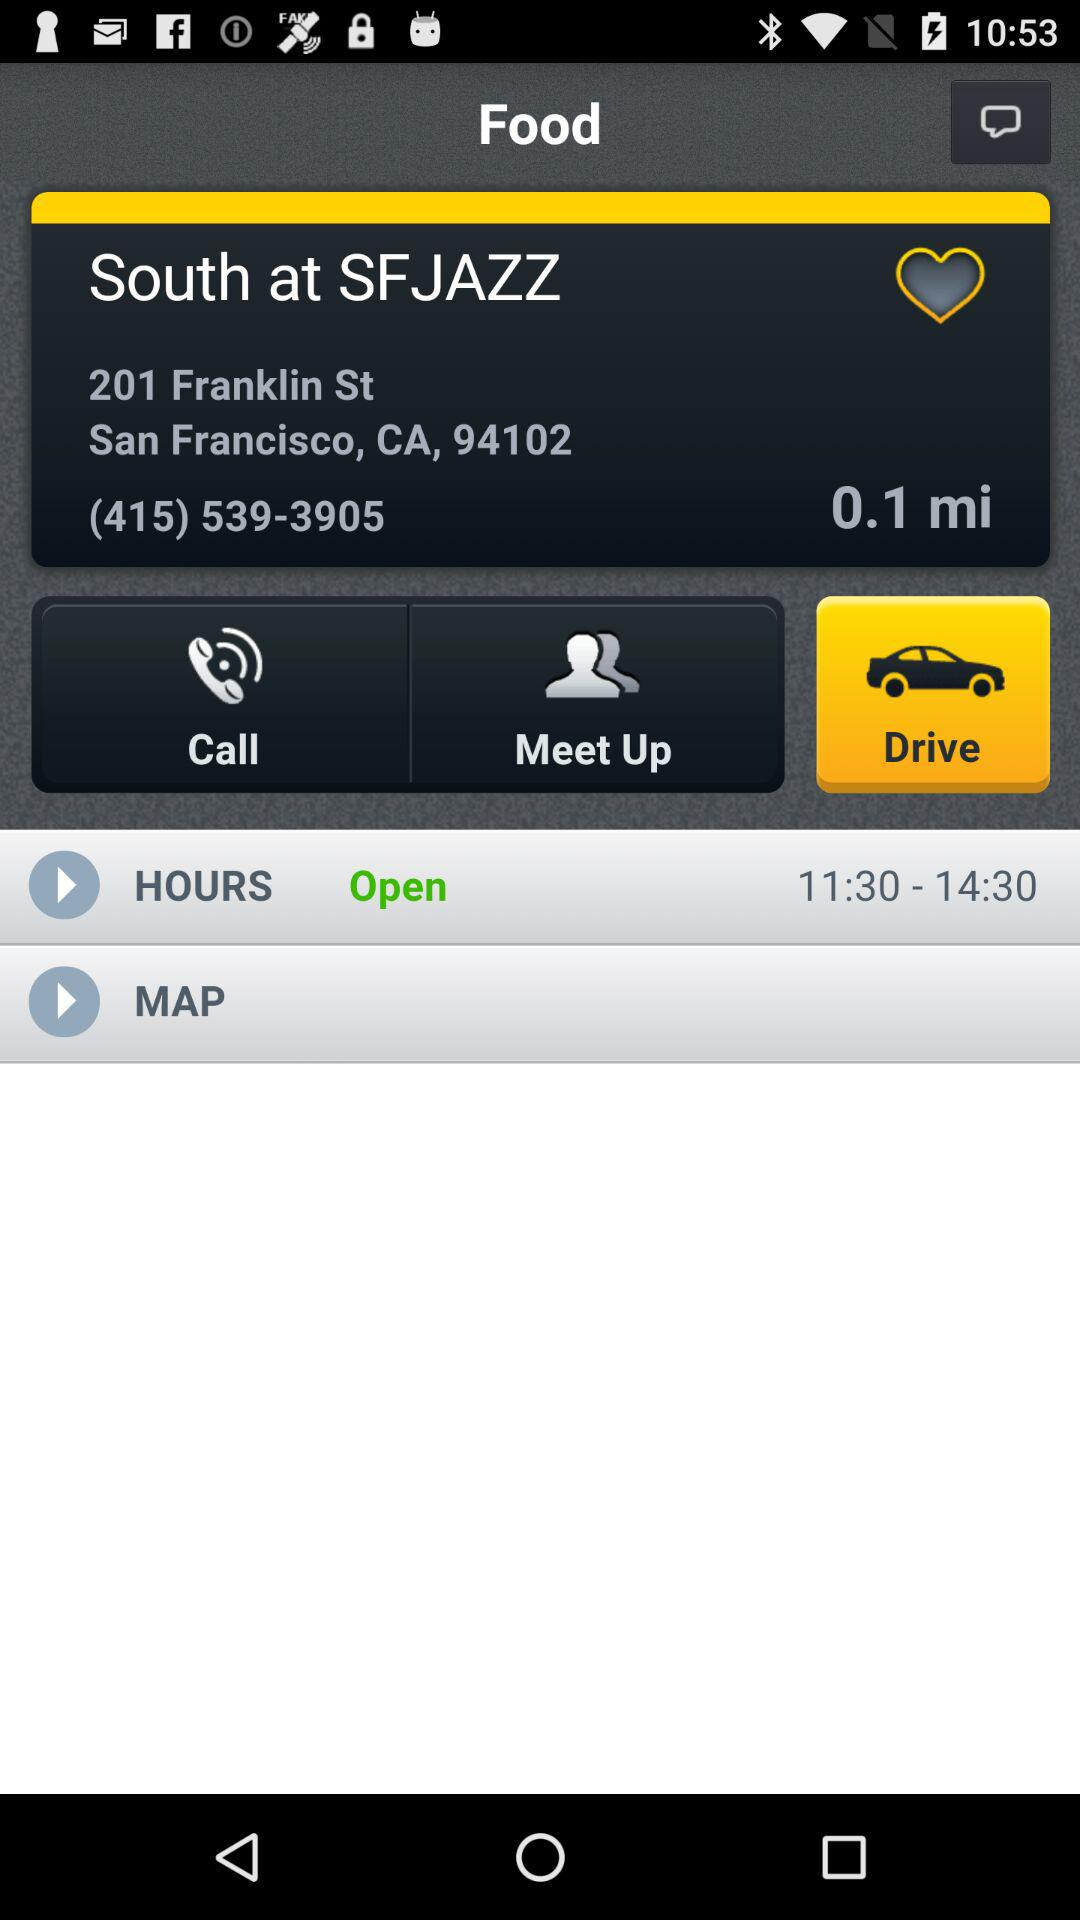What is the phone number for the business?
Answer the question using a single word or phrase. (415) 539-3905 